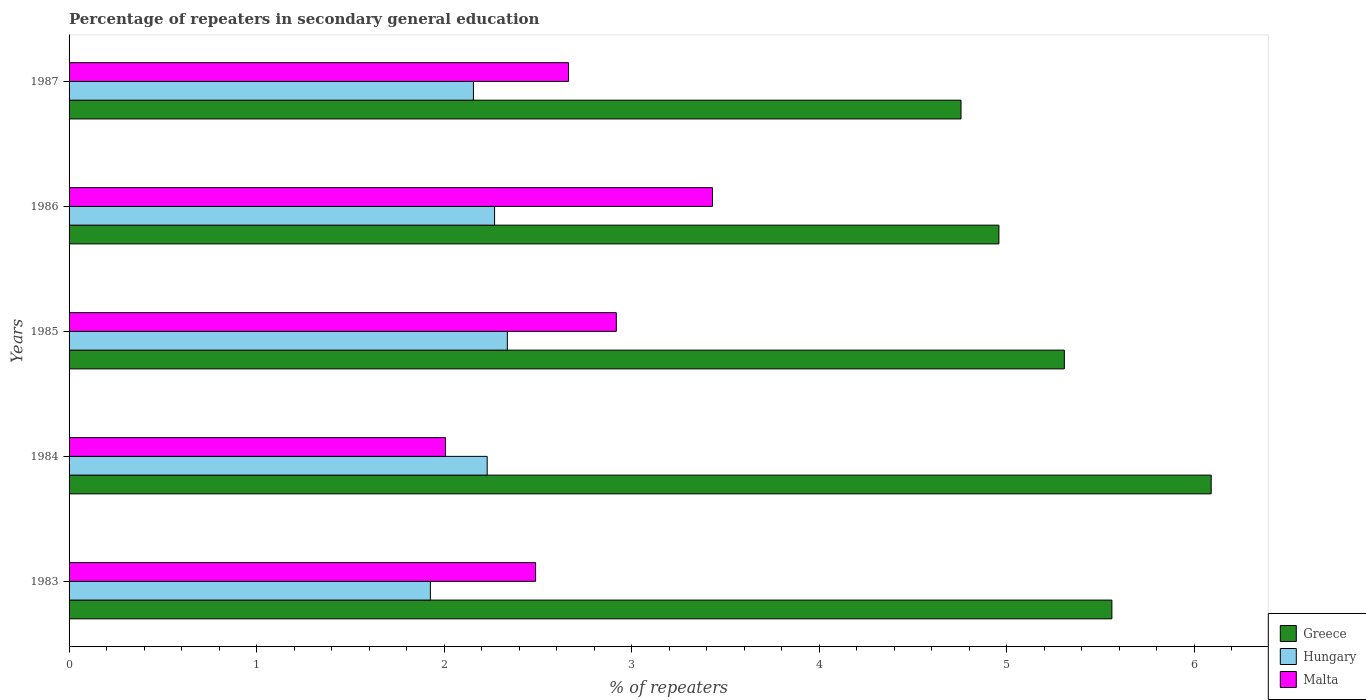How many bars are there on the 4th tick from the top?
Give a very brief answer. 3. What is the label of the 1st group of bars from the top?
Give a very brief answer. 1987. What is the percentage of repeaters in secondary general education in Hungary in 1983?
Ensure brevity in your answer.  1.93. Across all years, what is the maximum percentage of repeaters in secondary general education in Hungary?
Make the answer very short. 2.34. Across all years, what is the minimum percentage of repeaters in secondary general education in Greece?
Your answer should be compact. 4.76. In which year was the percentage of repeaters in secondary general education in Malta maximum?
Your response must be concise. 1986. What is the total percentage of repeaters in secondary general education in Greece in the graph?
Offer a terse response. 26.67. What is the difference between the percentage of repeaters in secondary general education in Hungary in 1983 and that in 1985?
Make the answer very short. -0.41. What is the difference between the percentage of repeaters in secondary general education in Hungary in 1986 and the percentage of repeaters in secondary general education in Greece in 1984?
Provide a succinct answer. -3.82. What is the average percentage of repeaters in secondary general education in Hungary per year?
Keep it short and to the point. 2.18. In the year 1983, what is the difference between the percentage of repeaters in secondary general education in Malta and percentage of repeaters in secondary general education in Greece?
Your response must be concise. -3.07. In how many years, is the percentage of repeaters in secondary general education in Greece greater than 2.6 %?
Your response must be concise. 5. What is the ratio of the percentage of repeaters in secondary general education in Hungary in 1983 to that in 1986?
Offer a terse response. 0.85. Is the percentage of repeaters in secondary general education in Hungary in 1983 less than that in 1986?
Make the answer very short. Yes. Is the difference between the percentage of repeaters in secondary general education in Malta in 1985 and 1986 greater than the difference between the percentage of repeaters in secondary general education in Greece in 1985 and 1986?
Give a very brief answer. No. What is the difference between the highest and the second highest percentage of repeaters in secondary general education in Greece?
Keep it short and to the point. 0.53. What is the difference between the highest and the lowest percentage of repeaters in secondary general education in Malta?
Keep it short and to the point. 1.42. Is the sum of the percentage of repeaters in secondary general education in Malta in 1985 and 1986 greater than the maximum percentage of repeaters in secondary general education in Hungary across all years?
Your answer should be very brief. Yes. What does the 2nd bar from the top in 1985 represents?
Your response must be concise. Hungary. What does the 2nd bar from the bottom in 1987 represents?
Your response must be concise. Hungary. Is it the case that in every year, the sum of the percentage of repeaters in secondary general education in Malta and percentage of repeaters in secondary general education in Hungary is greater than the percentage of repeaters in secondary general education in Greece?
Make the answer very short. No. How many bars are there?
Keep it short and to the point. 15. What is the difference between two consecutive major ticks on the X-axis?
Ensure brevity in your answer.  1. Does the graph contain grids?
Your answer should be compact. No. How many legend labels are there?
Your answer should be very brief. 3. What is the title of the graph?
Provide a short and direct response. Percentage of repeaters in secondary general education. What is the label or title of the X-axis?
Keep it short and to the point. % of repeaters. What is the % of repeaters in Greece in 1983?
Ensure brevity in your answer.  5.56. What is the % of repeaters in Hungary in 1983?
Your answer should be very brief. 1.93. What is the % of repeaters in Malta in 1983?
Ensure brevity in your answer.  2.49. What is the % of repeaters in Greece in 1984?
Keep it short and to the point. 6.09. What is the % of repeaters in Hungary in 1984?
Ensure brevity in your answer.  2.23. What is the % of repeaters in Malta in 1984?
Provide a short and direct response. 2.01. What is the % of repeaters of Greece in 1985?
Give a very brief answer. 5.31. What is the % of repeaters of Hungary in 1985?
Offer a very short reply. 2.34. What is the % of repeaters in Malta in 1985?
Provide a short and direct response. 2.92. What is the % of repeaters in Greece in 1986?
Offer a very short reply. 4.96. What is the % of repeaters of Hungary in 1986?
Your answer should be very brief. 2.27. What is the % of repeaters of Malta in 1986?
Offer a very short reply. 3.43. What is the % of repeaters in Greece in 1987?
Provide a short and direct response. 4.76. What is the % of repeaters of Hungary in 1987?
Offer a very short reply. 2.16. What is the % of repeaters in Malta in 1987?
Keep it short and to the point. 2.66. Across all years, what is the maximum % of repeaters of Greece?
Give a very brief answer. 6.09. Across all years, what is the maximum % of repeaters of Hungary?
Provide a short and direct response. 2.34. Across all years, what is the maximum % of repeaters of Malta?
Offer a terse response. 3.43. Across all years, what is the minimum % of repeaters of Greece?
Offer a terse response. 4.76. Across all years, what is the minimum % of repeaters in Hungary?
Your response must be concise. 1.93. Across all years, what is the minimum % of repeaters in Malta?
Offer a terse response. 2.01. What is the total % of repeaters in Greece in the graph?
Your answer should be compact. 26.67. What is the total % of repeaters in Hungary in the graph?
Provide a succinct answer. 10.92. What is the total % of repeaters in Malta in the graph?
Make the answer very short. 13.51. What is the difference between the % of repeaters in Greece in 1983 and that in 1984?
Provide a short and direct response. -0.53. What is the difference between the % of repeaters in Hungary in 1983 and that in 1984?
Make the answer very short. -0.3. What is the difference between the % of repeaters of Malta in 1983 and that in 1984?
Give a very brief answer. 0.48. What is the difference between the % of repeaters of Greece in 1983 and that in 1985?
Give a very brief answer. 0.25. What is the difference between the % of repeaters in Hungary in 1983 and that in 1985?
Make the answer very short. -0.41. What is the difference between the % of repeaters in Malta in 1983 and that in 1985?
Your answer should be very brief. -0.43. What is the difference between the % of repeaters in Greece in 1983 and that in 1986?
Offer a very short reply. 0.6. What is the difference between the % of repeaters of Hungary in 1983 and that in 1986?
Offer a very short reply. -0.34. What is the difference between the % of repeaters in Malta in 1983 and that in 1986?
Give a very brief answer. -0.94. What is the difference between the % of repeaters of Greece in 1983 and that in 1987?
Provide a short and direct response. 0.8. What is the difference between the % of repeaters in Hungary in 1983 and that in 1987?
Give a very brief answer. -0.23. What is the difference between the % of repeaters in Malta in 1983 and that in 1987?
Keep it short and to the point. -0.18. What is the difference between the % of repeaters in Greece in 1984 and that in 1985?
Ensure brevity in your answer.  0.78. What is the difference between the % of repeaters in Hungary in 1984 and that in 1985?
Ensure brevity in your answer.  -0.11. What is the difference between the % of repeaters in Malta in 1984 and that in 1985?
Give a very brief answer. -0.91. What is the difference between the % of repeaters in Greece in 1984 and that in 1986?
Your response must be concise. 1.13. What is the difference between the % of repeaters of Hungary in 1984 and that in 1986?
Provide a short and direct response. -0.04. What is the difference between the % of repeaters in Malta in 1984 and that in 1986?
Your response must be concise. -1.42. What is the difference between the % of repeaters of Greece in 1984 and that in 1987?
Provide a succinct answer. 1.33. What is the difference between the % of repeaters of Hungary in 1984 and that in 1987?
Provide a succinct answer. 0.07. What is the difference between the % of repeaters in Malta in 1984 and that in 1987?
Your response must be concise. -0.66. What is the difference between the % of repeaters in Greece in 1985 and that in 1986?
Offer a terse response. 0.35. What is the difference between the % of repeaters of Hungary in 1985 and that in 1986?
Your answer should be compact. 0.07. What is the difference between the % of repeaters of Malta in 1985 and that in 1986?
Provide a succinct answer. -0.51. What is the difference between the % of repeaters of Greece in 1985 and that in 1987?
Give a very brief answer. 0.55. What is the difference between the % of repeaters in Hungary in 1985 and that in 1987?
Your response must be concise. 0.18. What is the difference between the % of repeaters of Malta in 1985 and that in 1987?
Your answer should be very brief. 0.25. What is the difference between the % of repeaters of Greece in 1986 and that in 1987?
Give a very brief answer. 0.2. What is the difference between the % of repeaters in Hungary in 1986 and that in 1987?
Give a very brief answer. 0.11. What is the difference between the % of repeaters of Malta in 1986 and that in 1987?
Your answer should be very brief. 0.77. What is the difference between the % of repeaters in Greece in 1983 and the % of repeaters in Hungary in 1984?
Your response must be concise. 3.33. What is the difference between the % of repeaters in Greece in 1983 and the % of repeaters in Malta in 1984?
Your answer should be compact. 3.55. What is the difference between the % of repeaters of Hungary in 1983 and the % of repeaters of Malta in 1984?
Offer a very short reply. -0.08. What is the difference between the % of repeaters of Greece in 1983 and the % of repeaters of Hungary in 1985?
Make the answer very short. 3.22. What is the difference between the % of repeaters of Greece in 1983 and the % of repeaters of Malta in 1985?
Your answer should be compact. 2.64. What is the difference between the % of repeaters of Hungary in 1983 and the % of repeaters of Malta in 1985?
Offer a terse response. -0.99. What is the difference between the % of repeaters in Greece in 1983 and the % of repeaters in Hungary in 1986?
Your answer should be very brief. 3.29. What is the difference between the % of repeaters of Greece in 1983 and the % of repeaters of Malta in 1986?
Ensure brevity in your answer.  2.13. What is the difference between the % of repeaters in Hungary in 1983 and the % of repeaters in Malta in 1986?
Offer a terse response. -1.5. What is the difference between the % of repeaters of Greece in 1983 and the % of repeaters of Hungary in 1987?
Provide a succinct answer. 3.4. What is the difference between the % of repeaters in Greece in 1983 and the % of repeaters in Malta in 1987?
Your answer should be compact. 2.9. What is the difference between the % of repeaters of Hungary in 1983 and the % of repeaters of Malta in 1987?
Ensure brevity in your answer.  -0.74. What is the difference between the % of repeaters in Greece in 1984 and the % of repeaters in Hungary in 1985?
Make the answer very short. 3.75. What is the difference between the % of repeaters of Greece in 1984 and the % of repeaters of Malta in 1985?
Make the answer very short. 3.17. What is the difference between the % of repeaters of Hungary in 1984 and the % of repeaters of Malta in 1985?
Your response must be concise. -0.69. What is the difference between the % of repeaters of Greece in 1984 and the % of repeaters of Hungary in 1986?
Your answer should be compact. 3.82. What is the difference between the % of repeaters of Greece in 1984 and the % of repeaters of Malta in 1986?
Make the answer very short. 2.66. What is the difference between the % of repeaters in Hungary in 1984 and the % of repeaters in Malta in 1986?
Your response must be concise. -1.2. What is the difference between the % of repeaters in Greece in 1984 and the % of repeaters in Hungary in 1987?
Make the answer very short. 3.93. What is the difference between the % of repeaters in Greece in 1984 and the % of repeaters in Malta in 1987?
Provide a succinct answer. 3.43. What is the difference between the % of repeaters in Hungary in 1984 and the % of repeaters in Malta in 1987?
Provide a short and direct response. -0.43. What is the difference between the % of repeaters in Greece in 1985 and the % of repeaters in Hungary in 1986?
Your answer should be compact. 3.04. What is the difference between the % of repeaters of Greece in 1985 and the % of repeaters of Malta in 1986?
Provide a succinct answer. 1.88. What is the difference between the % of repeaters in Hungary in 1985 and the % of repeaters in Malta in 1986?
Your answer should be very brief. -1.09. What is the difference between the % of repeaters in Greece in 1985 and the % of repeaters in Hungary in 1987?
Ensure brevity in your answer.  3.15. What is the difference between the % of repeaters of Greece in 1985 and the % of repeaters of Malta in 1987?
Your answer should be compact. 2.64. What is the difference between the % of repeaters in Hungary in 1985 and the % of repeaters in Malta in 1987?
Offer a terse response. -0.33. What is the difference between the % of repeaters of Greece in 1986 and the % of repeaters of Hungary in 1987?
Your response must be concise. 2.8. What is the difference between the % of repeaters of Greece in 1986 and the % of repeaters of Malta in 1987?
Ensure brevity in your answer.  2.29. What is the difference between the % of repeaters in Hungary in 1986 and the % of repeaters in Malta in 1987?
Your answer should be compact. -0.39. What is the average % of repeaters of Greece per year?
Make the answer very short. 5.33. What is the average % of repeaters of Hungary per year?
Keep it short and to the point. 2.18. What is the average % of repeaters in Malta per year?
Your answer should be very brief. 2.7. In the year 1983, what is the difference between the % of repeaters in Greece and % of repeaters in Hungary?
Offer a terse response. 3.63. In the year 1983, what is the difference between the % of repeaters of Greece and % of repeaters of Malta?
Keep it short and to the point. 3.07. In the year 1983, what is the difference between the % of repeaters in Hungary and % of repeaters in Malta?
Give a very brief answer. -0.56. In the year 1984, what is the difference between the % of repeaters in Greece and % of repeaters in Hungary?
Your response must be concise. 3.86. In the year 1984, what is the difference between the % of repeaters in Greece and % of repeaters in Malta?
Your answer should be very brief. 4.08. In the year 1984, what is the difference between the % of repeaters of Hungary and % of repeaters of Malta?
Your response must be concise. 0.22. In the year 1985, what is the difference between the % of repeaters in Greece and % of repeaters in Hungary?
Make the answer very short. 2.97. In the year 1985, what is the difference between the % of repeaters in Greece and % of repeaters in Malta?
Give a very brief answer. 2.39. In the year 1985, what is the difference between the % of repeaters in Hungary and % of repeaters in Malta?
Keep it short and to the point. -0.58. In the year 1986, what is the difference between the % of repeaters in Greece and % of repeaters in Hungary?
Offer a terse response. 2.69. In the year 1986, what is the difference between the % of repeaters of Greece and % of repeaters of Malta?
Offer a terse response. 1.53. In the year 1986, what is the difference between the % of repeaters in Hungary and % of repeaters in Malta?
Provide a short and direct response. -1.16. In the year 1987, what is the difference between the % of repeaters of Greece and % of repeaters of Hungary?
Give a very brief answer. 2.6. In the year 1987, what is the difference between the % of repeaters of Greece and % of repeaters of Malta?
Offer a very short reply. 2.09. In the year 1987, what is the difference between the % of repeaters in Hungary and % of repeaters in Malta?
Your response must be concise. -0.51. What is the ratio of the % of repeaters of Greece in 1983 to that in 1984?
Keep it short and to the point. 0.91. What is the ratio of the % of repeaters in Hungary in 1983 to that in 1984?
Provide a succinct answer. 0.86. What is the ratio of the % of repeaters in Malta in 1983 to that in 1984?
Your answer should be compact. 1.24. What is the ratio of the % of repeaters in Greece in 1983 to that in 1985?
Make the answer very short. 1.05. What is the ratio of the % of repeaters in Hungary in 1983 to that in 1985?
Offer a very short reply. 0.82. What is the ratio of the % of repeaters in Malta in 1983 to that in 1985?
Make the answer very short. 0.85. What is the ratio of the % of repeaters in Greece in 1983 to that in 1986?
Offer a very short reply. 1.12. What is the ratio of the % of repeaters in Hungary in 1983 to that in 1986?
Offer a very short reply. 0.85. What is the ratio of the % of repeaters in Malta in 1983 to that in 1986?
Provide a succinct answer. 0.73. What is the ratio of the % of repeaters of Greece in 1983 to that in 1987?
Keep it short and to the point. 1.17. What is the ratio of the % of repeaters of Hungary in 1983 to that in 1987?
Offer a very short reply. 0.89. What is the ratio of the % of repeaters in Malta in 1983 to that in 1987?
Provide a short and direct response. 0.93. What is the ratio of the % of repeaters in Greece in 1984 to that in 1985?
Provide a short and direct response. 1.15. What is the ratio of the % of repeaters of Hungary in 1984 to that in 1985?
Keep it short and to the point. 0.95. What is the ratio of the % of repeaters of Malta in 1984 to that in 1985?
Provide a succinct answer. 0.69. What is the ratio of the % of repeaters in Greece in 1984 to that in 1986?
Keep it short and to the point. 1.23. What is the ratio of the % of repeaters of Hungary in 1984 to that in 1986?
Your answer should be compact. 0.98. What is the ratio of the % of repeaters of Malta in 1984 to that in 1986?
Make the answer very short. 0.59. What is the ratio of the % of repeaters of Greece in 1984 to that in 1987?
Provide a short and direct response. 1.28. What is the ratio of the % of repeaters in Hungary in 1984 to that in 1987?
Provide a short and direct response. 1.03. What is the ratio of the % of repeaters of Malta in 1984 to that in 1987?
Give a very brief answer. 0.75. What is the ratio of the % of repeaters in Greece in 1985 to that in 1986?
Offer a terse response. 1.07. What is the ratio of the % of repeaters of Malta in 1985 to that in 1986?
Offer a terse response. 0.85. What is the ratio of the % of repeaters of Greece in 1985 to that in 1987?
Ensure brevity in your answer.  1.12. What is the ratio of the % of repeaters of Hungary in 1985 to that in 1987?
Your answer should be very brief. 1.08. What is the ratio of the % of repeaters in Malta in 1985 to that in 1987?
Provide a succinct answer. 1.1. What is the ratio of the % of repeaters in Greece in 1986 to that in 1987?
Ensure brevity in your answer.  1.04. What is the ratio of the % of repeaters in Hungary in 1986 to that in 1987?
Make the answer very short. 1.05. What is the ratio of the % of repeaters of Malta in 1986 to that in 1987?
Keep it short and to the point. 1.29. What is the difference between the highest and the second highest % of repeaters in Greece?
Offer a terse response. 0.53. What is the difference between the highest and the second highest % of repeaters of Hungary?
Ensure brevity in your answer.  0.07. What is the difference between the highest and the second highest % of repeaters of Malta?
Your answer should be compact. 0.51. What is the difference between the highest and the lowest % of repeaters of Greece?
Provide a short and direct response. 1.33. What is the difference between the highest and the lowest % of repeaters in Hungary?
Provide a short and direct response. 0.41. What is the difference between the highest and the lowest % of repeaters in Malta?
Provide a succinct answer. 1.42. 